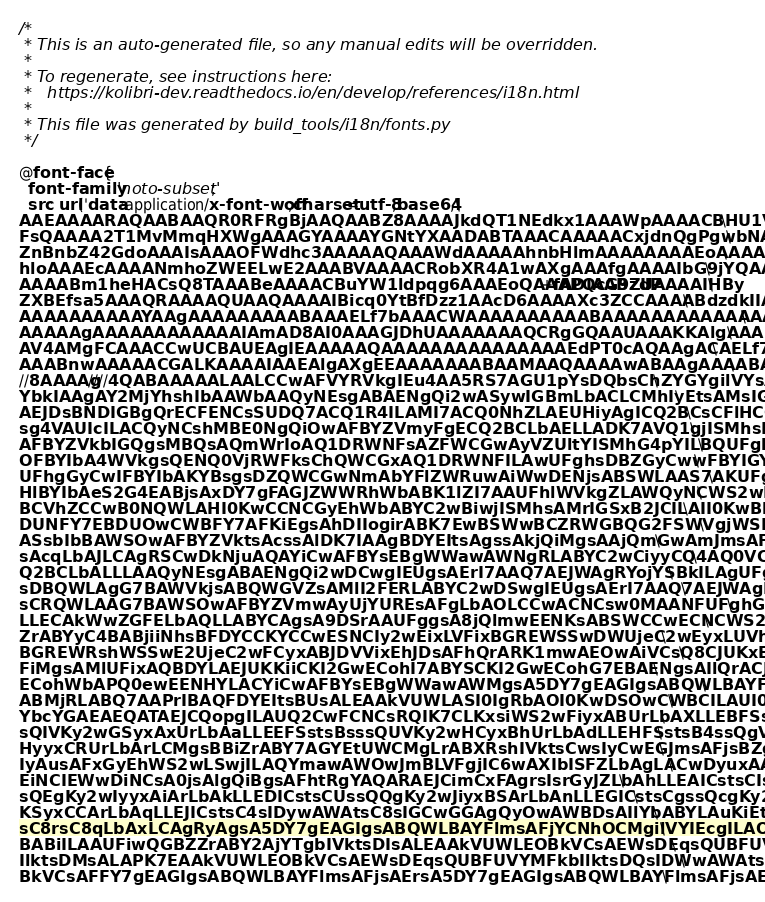<code> <loc_0><loc_0><loc_500><loc_500><_CSS_>
/*
 * This is an auto-generated file, so any manual edits will be overridden.
 *
 * To regenerate, see instructions here:
 *   https://kolibri-dev.readthedocs.io/en/develop/references/i18n.html
 *
 * This file was generated by build_tools/i18n/fonts.py
 */

@font-face {
  font-family: 'noto-subset';
  src: url('data:application/x-font-woff;charset=utf-8;base64,\
AAEAAAARAQAABAAQR0RFRgBjAAQAABZ8AAAAJkdQT1NEdkx1AAAWpAAAACBHU1VCkxWCFgAA\
FsQAAAA2T1MvMmqHXWgAAAGYAAAAYGNtYXAADABTAAACAAAAACxjdnQgPgwbNAAAEUwAAAEs\
ZnBnbZ42GdoAAAIsAAAOFWdhc3AAAAAQAAAWdAAAAAhnbHlmAAAAAAAAEoAAAAABaGVhZM3j\
hloAAAEcAAAANmhoZWEELwE2AAABVAAAACRobXR4A1wAXgAAAfgAAAAIbG9jYQAAAAAAABJ4\
AAAABm1heHACsQ8TAAABeAAAACBuYW1ldpqg6AAAEoQAAAPQcG9zdP+fADIAABZUAAAAIHBy\
ZXBEfsa5AAAQRAAAAQUAAQAAAAIBicq0YtBfDzz1AAcD6AAAAXc3ZCCAAAABdzdkIIAAAAAA\
AAAAAAAAAAYAAgAAAAAAAAABAAAELf7bAAACWAAAAAAAAAABAAAAAAAAAAAAAAAAAAAAAgAB\
AAAAAgAAAAAAAAAAAAIAmAD8AI0AAAGJDhUAAAAAAAQCRgGQAAUAAAKKAlgAAABLAooCWAAA\
AV4AMgFCAAACCwUCBAUEAgIEAAAAAQAAAAAAAAAAAAAAAEdPT0cAQAAgACAELf7bAAAELQEl\
AAABnwAAAAACGALKAAAAIAAEAlgAXgEEAAAAAAABAAMAAQAAAAwABAAgAAAABAAEAAEAAAAg\
//8AAAAg////4QABAAAAALAALCCwAFVYRVkgIEu4AA5RS7AGU1pYsDQbsChZYGYgilVYsAIl\
YbkIAAgAY2MjYhshIbAAWbAAQyNEsgABAENgQi2wASywIGBmLbACLCMhIyEtsAMsIGSzAxQV\
AEJDsBNDIGBgQrECFENCsSUDQ7ACQ1R4ILAMI7ACQ0NhZLAEUHiyAgICQ2BCsCFlHCGwAkND\
sg4VAUIcILACQyNCshMBE0NgQiOwAFBYZVmyFgECQ2BCLbAELLADK7AVQ1gjISMhsBZDQyOw\
AFBYZVkbIGQgsMBQsAQmWrIoAQ1DRWNFsAZFWCGwAyVZUltYISMhG4pYILBQUFghsEBZGyCw\
OFBYIbA4WVkgsQENQ0VjRWFksChQWCGxAQ1DRWNFILAwUFghsDBZGyCwwFBYIGYgiophILAK\
UFhgGyCwIFBYIbAKYBsgsDZQWCGwNmAbYFlZWRuwAiWwDENjsABSWLAAS7AKUFghsAxDG0uw\
HlBYIbAeS2G4EABjsAxDY7gFAGJZWWRhWbABK1lZI7AAUFhlWVkgZLAWQyNCWS2wBSwgRSCw\
BCVhZCCwB0NQWLAHI0KwCCNCGyEhWbABYC2wBiwjISMhsAMrIGSxB2JCILAII0KwBkVYG7EB\
DUNFY7EBDUOwCWBFY7AFKiEgsAhDIIogirABK7EwBSWwBCZRWGBQG2FSWVgjWSFZILBAU1iw\
ASsbIbBAWSOwAFBYZVktsAcssAlDK7IAAgBDYEItsAgssAkjQiMgsAAjQmGwAmJmsAFjsAFg\
sAcqLbAJLCAgRSCwDkNjuAQAYiCwAFBYsEBgWWawAWNgRLABYC2wCiyyCQ4AQ0VCKiGyAAEA\
Q2BCLbALLLAAQyNEsgABAENgQi2wDCwgIEUgsAErI7AAQ7AEJWAgRYojYSBkILAgUFghsAAb\
sDBQWLAgG7BAWVkjsABQWGVZsAMlI2FERLABYC2wDSwgIEUgsAErI7AAQ7AEJWAgRYojYSBk\
sCRQWLAAG7BAWSOwAFBYZVmwAyUjYUREsAFgLbAOLCCwACNCsw0MAANFUFghGyMhWSohLbAP\
LLECAkWwZGFELbAQLLABYCAgsA9DSrAAUFggsA8jQlmwEENKsABSWCCwECNCWS2wESwgsBBi\
ZrABYyC4BABjiiNhsBFDYCCKYCCwESNCIy2wEixLVFixBGREWSSwDWUjeC2wEyxLUVhLU1ix\
BGREWRshWSSwE2UjeC2wFCyxABJDVVixEhJDsAFhQrARK1mwAEOwAiVCsQ8CJUKxEAIlQrAB\
FiMgsAMlUFixAQBDYLAEJUKKiiCKI2GwECohI7ABYSCKI2GwECohG7EBAENgsAIlQrACJWGw\
ECohWbAPQ0ewEENHYLACYiCwAFBYsEBgWWawAWMgsA5DY7gEAGIgsABQWLBAYFlmsAFjYLEA\
ABMjRLABQ7AAPrIBAQFDYEItsBUsALEAAkVUWLASI0IgRbAOI0KwDSOwCWBCILAUI0IgYLAB\
YbcYGAEAEQATAEJCQopgILAUQ2CwFCNCsRQIK7CLKxsiWS2wFiyxABUrLbAXLLEBFSstsBgs\
sQIVKy2wGSyxAxUrLbAaLLEEFSstsBsssQUVKy2wHCyxBhUrLbAdLLEHFSstsB4ssQgVKy2w\
HyyxCRUrLbArLCMgsBBiZrABY7AGYEtUWCMgLrABXRshIVktsCwsIyCwEGJmsAFjsBZgS1RY\
IyAusAFxGyEhWS2wLSwjILAQYmawAWOwJmBLVFgjIC6wAXIbISFZLbAgLACwDyuxAAJFVFiw\
EiNCIEWwDiNCsA0jsAlgQiBgsAFhtRgYAQARAEJCimCxFAgrsIsrGyJZLbAhLLEAICstsCIs\
sQEgKy2wIyyxAiArLbAkLLEDICstsCUssQQgKy2wJiyxBSArLbAnLLEGICstsCgssQcgKy2w\
KSyxCCArLbAqLLEJICstsC4sIDywAWAtsC8sIGCwGGAgQyOwAWBDsAIlYbABYLAuKiEtsDAs\
sC8rsC8qLbAxLCAgRyAgsA5DY7gEAGIgsABQWLBAYFlmsAFjYCNhOCMgilVYIEcgILAOQ2O4\
BABiILAAUFiwQGBZZrABY2AjYTgbIVktsDIsALEAAkVUWLEOBkVCsAEWsDEqsQUBFUVYMFkb\
IlktsDMsALAPK7EAAkVUWLEOBkVCsAEWsDEqsQUBFUVYMFkbIlktsDQsIDWwAWAtsDUsALEO\
BkVCsAFFY7gEAGIgsABQWLBAYFlmsAFjsAErsA5DY7gEAGIgsABQWLBAYFlmsAFjsAErsAAW\</code> 